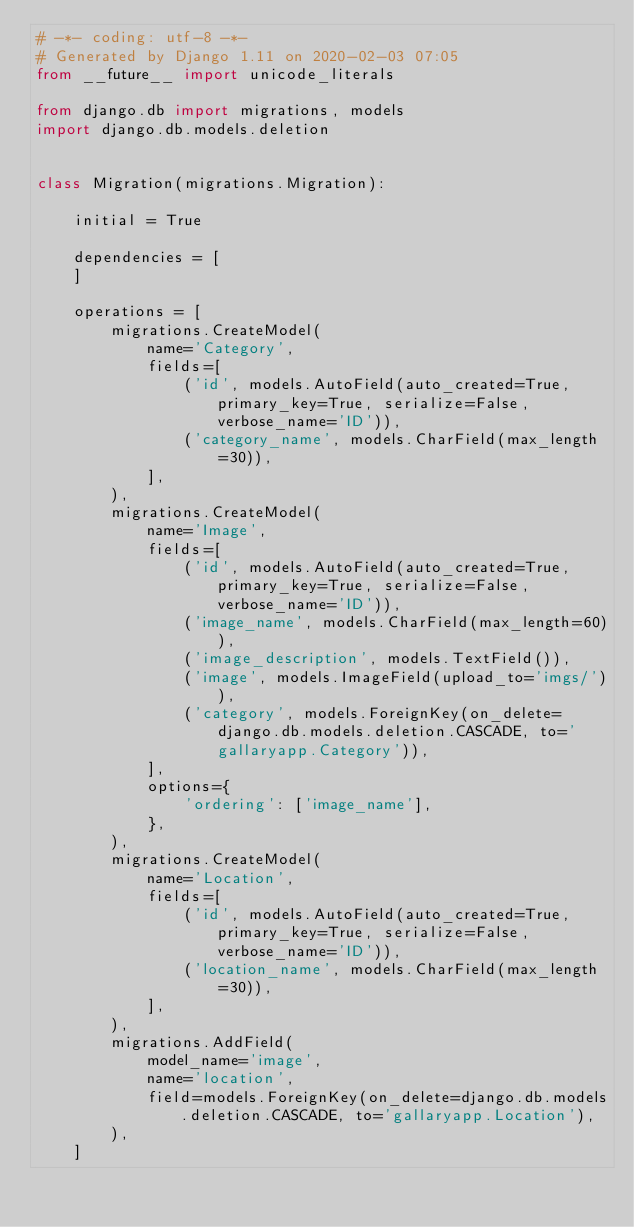<code> <loc_0><loc_0><loc_500><loc_500><_Python_># -*- coding: utf-8 -*-
# Generated by Django 1.11 on 2020-02-03 07:05
from __future__ import unicode_literals

from django.db import migrations, models
import django.db.models.deletion


class Migration(migrations.Migration):

    initial = True

    dependencies = [
    ]

    operations = [
        migrations.CreateModel(
            name='Category',
            fields=[
                ('id', models.AutoField(auto_created=True, primary_key=True, serialize=False, verbose_name='ID')),
                ('category_name', models.CharField(max_length=30)),
            ],
        ),
        migrations.CreateModel(
            name='Image',
            fields=[
                ('id', models.AutoField(auto_created=True, primary_key=True, serialize=False, verbose_name='ID')),
                ('image_name', models.CharField(max_length=60)),
                ('image_description', models.TextField()),
                ('image', models.ImageField(upload_to='imgs/')),
                ('category', models.ForeignKey(on_delete=django.db.models.deletion.CASCADE, to='gallaryapp.Category')),
            ],
            options={
                'ordering': ['image_name'],
            },
        ),
        migrations.CreateModel(
            name='Location',
            fields=[
                ('id', models.AutoField(auto_created=True, primary_key=True, serialize=False, verbose_name='ID')),
                ('location_name', models.CharField(max_length=30)),
            ],
        ),
        migrations.AddField(
            model_name='image',
            name='location',
            field=models.ForeignKey(on_delete=django.db.models.deletion.CASCADE, to='gallaryapp.Location'),
        ),
    ]
</code> 